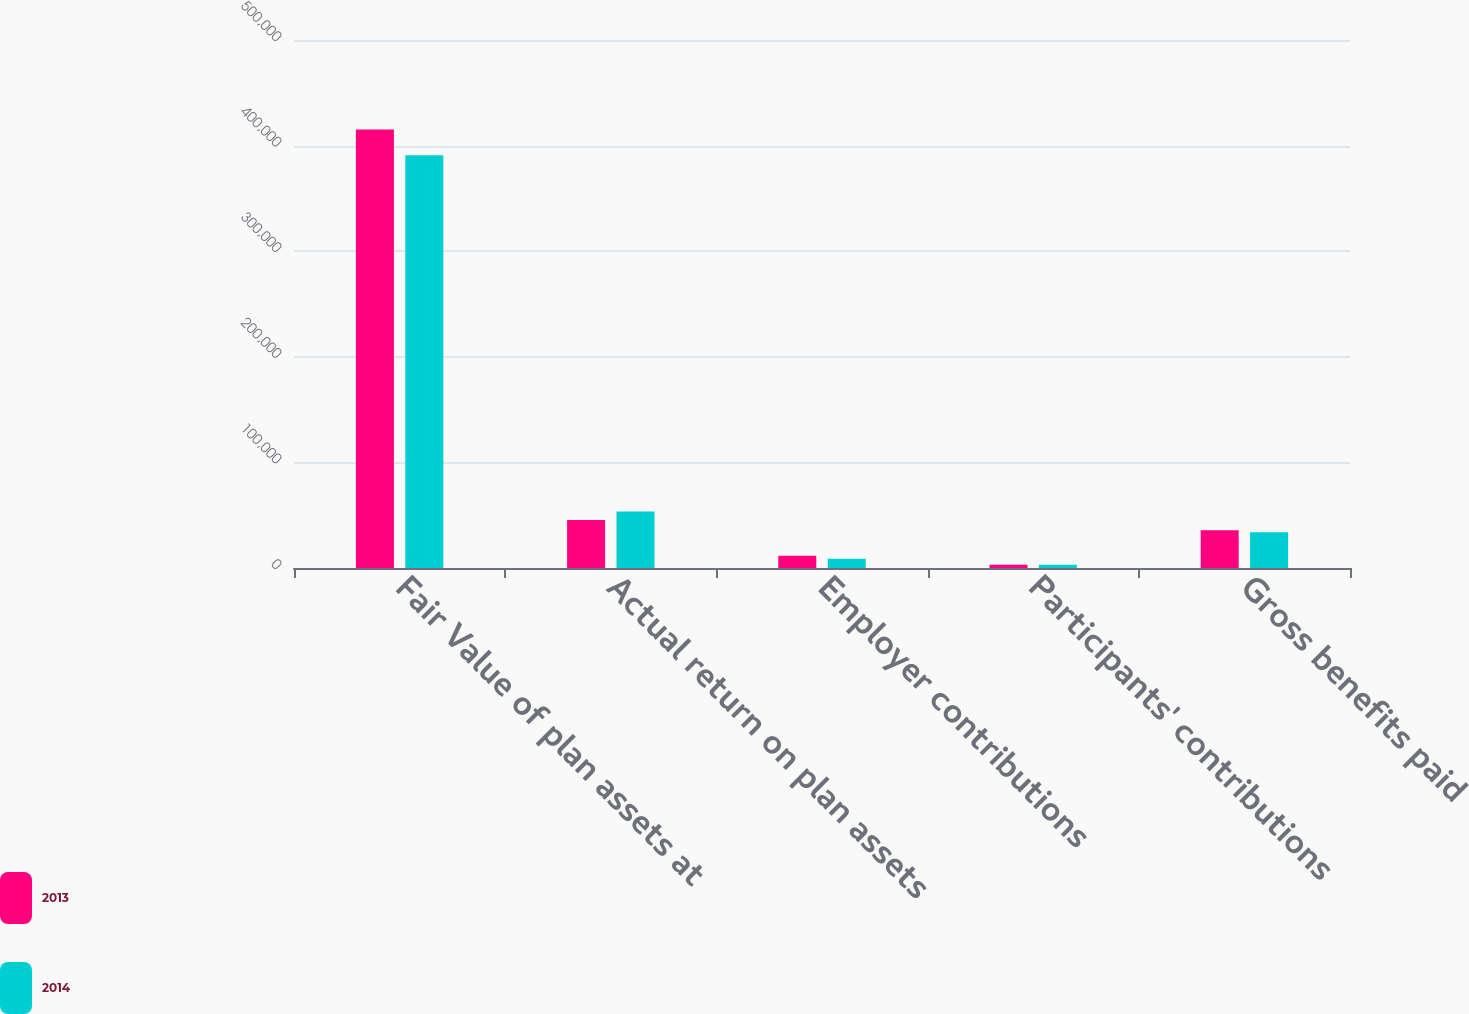Convert chart to OTSL. <chart><loc_0><loc_0><loc_500><loc_500><stacked_bar_chart><ecel><fcel>Fair Value of plan assets at<fcel>Actual return on plan assets<fcel>Employer contributions<fcel>Participants' contributions<fcel>Gross benefits paid<nl><fcel>2013<fcel>415350<fcel>45484<fcel>11628<fcel>3095<fcel>35634<nl><fcel>2014<fcel>390777<fcel>53495<fcel>8823<fcel>3071<fcel>33960<nl></chart> 